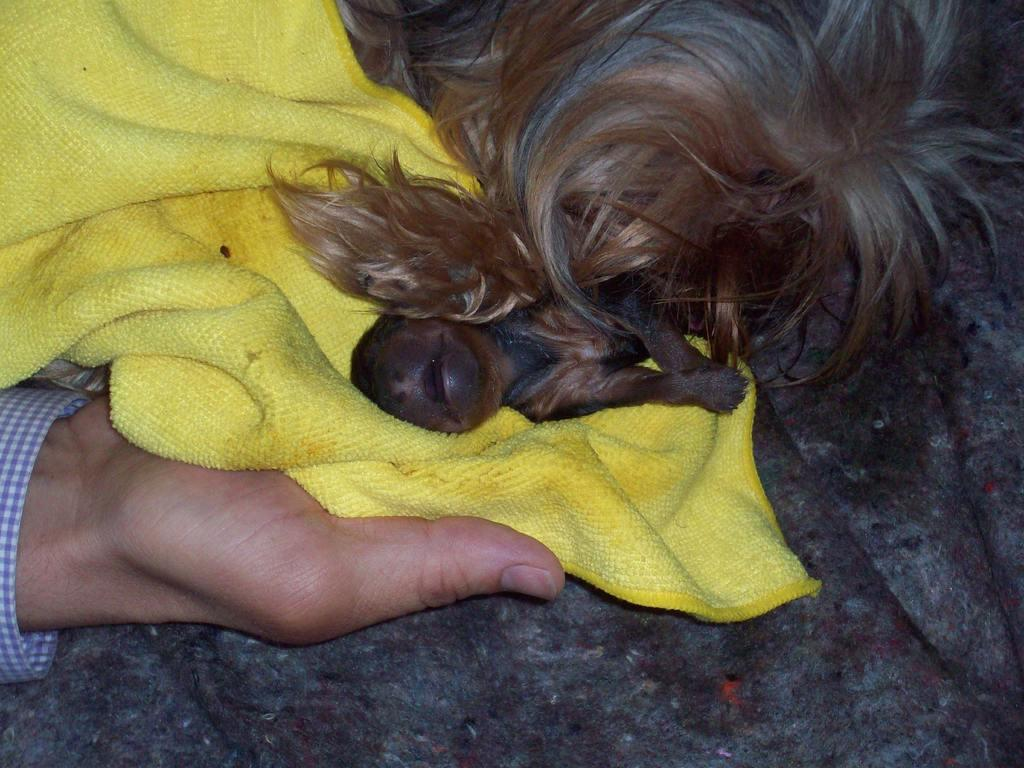Who or what is present in the image? There is a person in the image. What is the person doing in the image? The person is holding an animal. What else can be seen in the image besides the person and the animal? There are clothes visible in the image. What type of system is the person using to hold the animal in the image? There is no system mentioned or visible in the image; the person is simply holding the animal. 